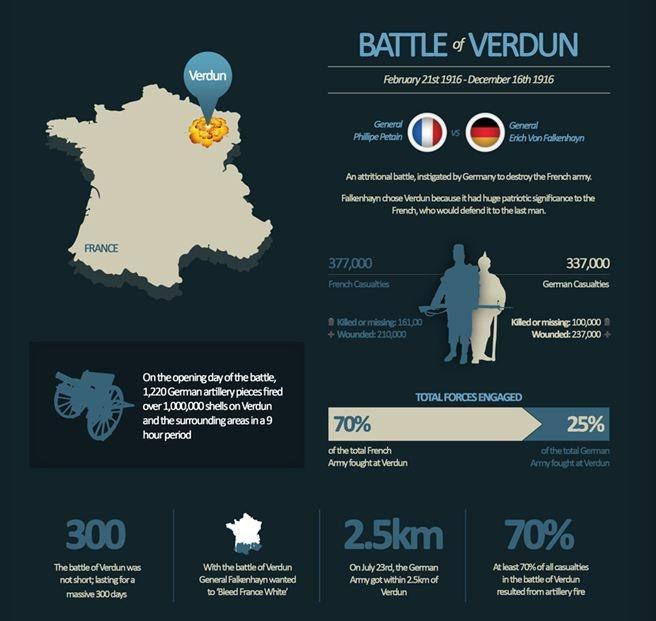How many German soldiers were dead or went missing in the Battle of Verdun?
Answer the question with a short phrase. 100,000 When did the Battle of Verdun end? December 16th 1916 How many French soldiers were wounded in the Battle of Verdun? 210,000 Who was the German General during the Battle of Verdun? Erich Von Falkenhayn How long (in days) was the battle of Verdun? 300 